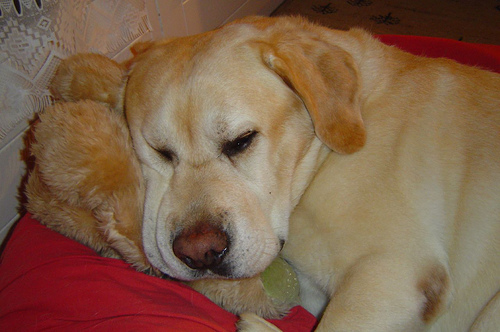What breed is the dog in the picture? The dog in the image appears to be a Labrador Retriever, one of the most popular breeds known for their friendly and outgoing nature. 